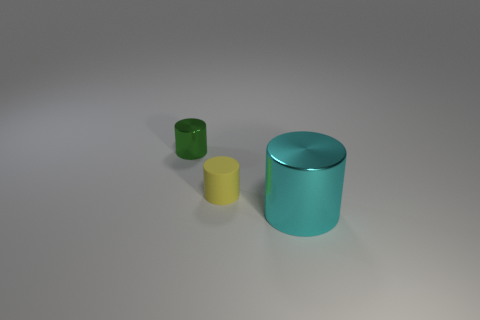Subtract all tiny cylinders. How many cylinders are left? 1 Subtract all yellow cylinders. How many cylinders are left? 2 Add 1 big blue objects. How many objects exist? 4 Add 1 big objects. How many big objects are left? 2 Add 1 yellow rubber cylinders. How many yellow rubber cylinders exist? 2 Subtract 1 green cylinders. How many objects are left? 2 Subtract all gray cylinders. Subtract all green cubes. How many cylinders are left? 3 Subtract all yellow cylinders. Subtract all big cyan objects. How many objects are left? 1 